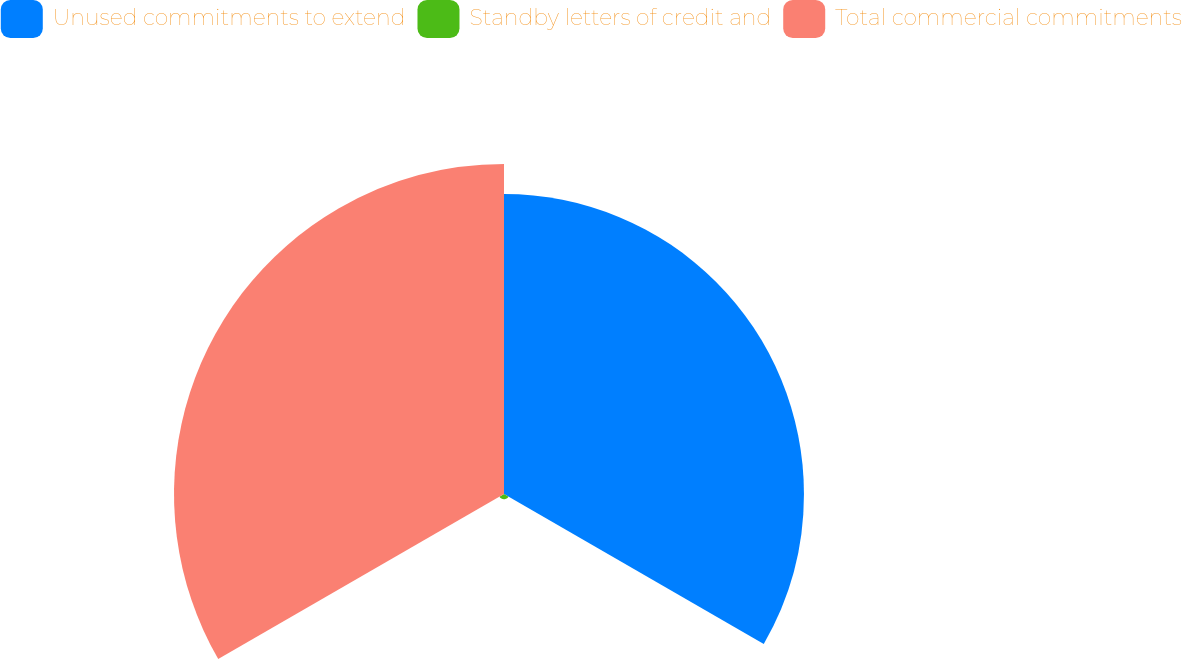Convert chart to OTSL. <chart><loc_0><loc_0><loc_500><loc_500><pie_chart><fcel>Unused commitments to extend<fcel>Standby letters of credit and<fcel>Total commercial commitments<nl><fcel>47.22%<fcel>0.83%<fcel>51.95%<nl></chart> 